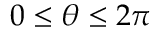Convert formula to latex. <formula><loc_0><loc_0><loc_500><loc_500>0 \leq \theta \leq 2 \pi</formula> 